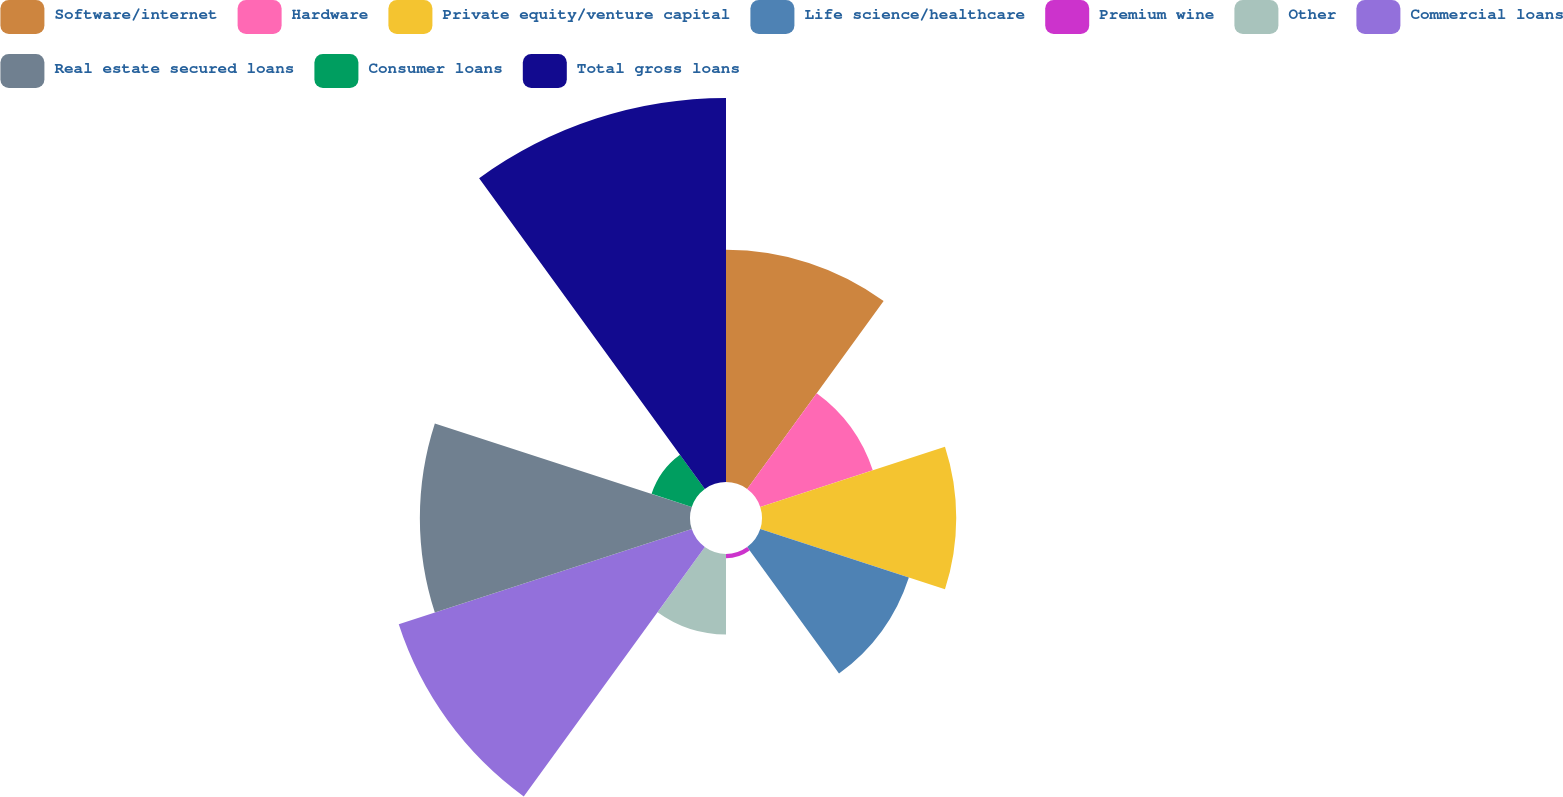<chart> <loc_0><loc_0><loc_500><loc_500><pie_chart><fcel>Software/internet<fcel>Hardware<fcel>Private equity/venture capital<fcel>Life science/healthcare<fcel>Premium wine<fcel>Other<fcel>Commercial loans<fcel>Real estate secured loans<fcel>Consumer loans<fcel>Total gross loans<nl><fcel>12.97%<fcel>6.61%<fcel>10.85%<fcel>8.73%<fcel>0.24%<fcel>4.49%<fcel>17.21%<fcel>15.09%<fcel>2.36%<fcel>21.45%<nl></chart> 